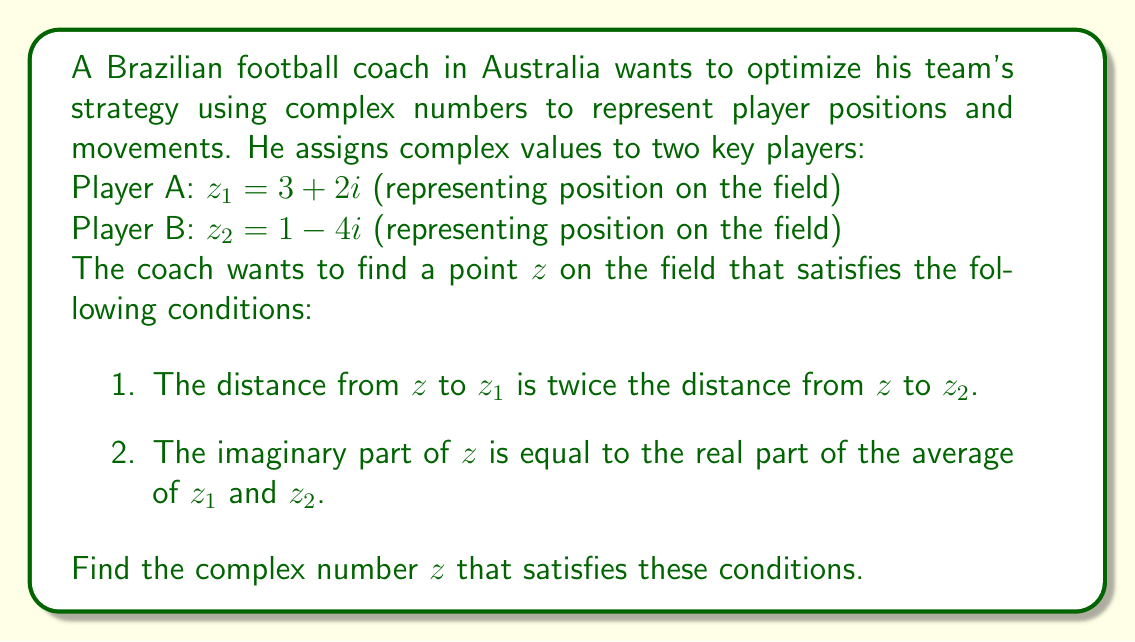Solve this math problem. Let's approach this step-by-step:

1) First, let's express the distances using the complex plane. The distance between two complex numbers is given by the absolute value of their difference. So, our first condition can be written as:

   $|z - z_1| = 2|z - z_2|$

2) Squaring both sides (to eliminate the absolute value):

   $(z - z_1)(z^* - z_1^*) = 4(z - z_2)(z^* - z_2^*)$

   Where $z^*$ denotes the complex conjugate of $z$.

3) Let $z = x + yi$. Then our second condition states:

   $y = \frac{Re(z_1) + Re(z_2)}{2} = \frac{3 + 1}{2} = 2$

4) So we know that $z = x + 2i$. Substituting this into the equation from step 2:

   $(x + 2i - (3 + 2i))(x - 2i - (3 - 2i)) = 4(x + 2i - (1 - 4i))(x - 2i - (1 + 4i))$

5) Simplifying:

   $((x - 3) + 0i)((x - 3) - 0i) = 4((x - 1) + 6i)((x - 1) - 6i)$

6) Further simplification:

   $(x - 3)^2 = 4((x - 1)^2 + 36)$

7) Expanding:

   $x^2 - 6x + 9 = 4x^2 - 8x + 148$

8) Rearranging:

   $3x^2 - 2x - 139 = 0$

9) This is a quadratic equation. We can solve it using the quadratic formula:

   $x = \frac{2 \pm \sqrt{4 + 4(3)(139)}}{2(3)} = \frac{2 \pm \sqrt{1672}}{6}$

10) The positive solution gives us:

    $x = \frac{2 + \sqrt{1672}}{6} \approx 7$

Therefore, $z \approx 7 + 2i$.
Answer: $z \approx 7 + 2i$ 